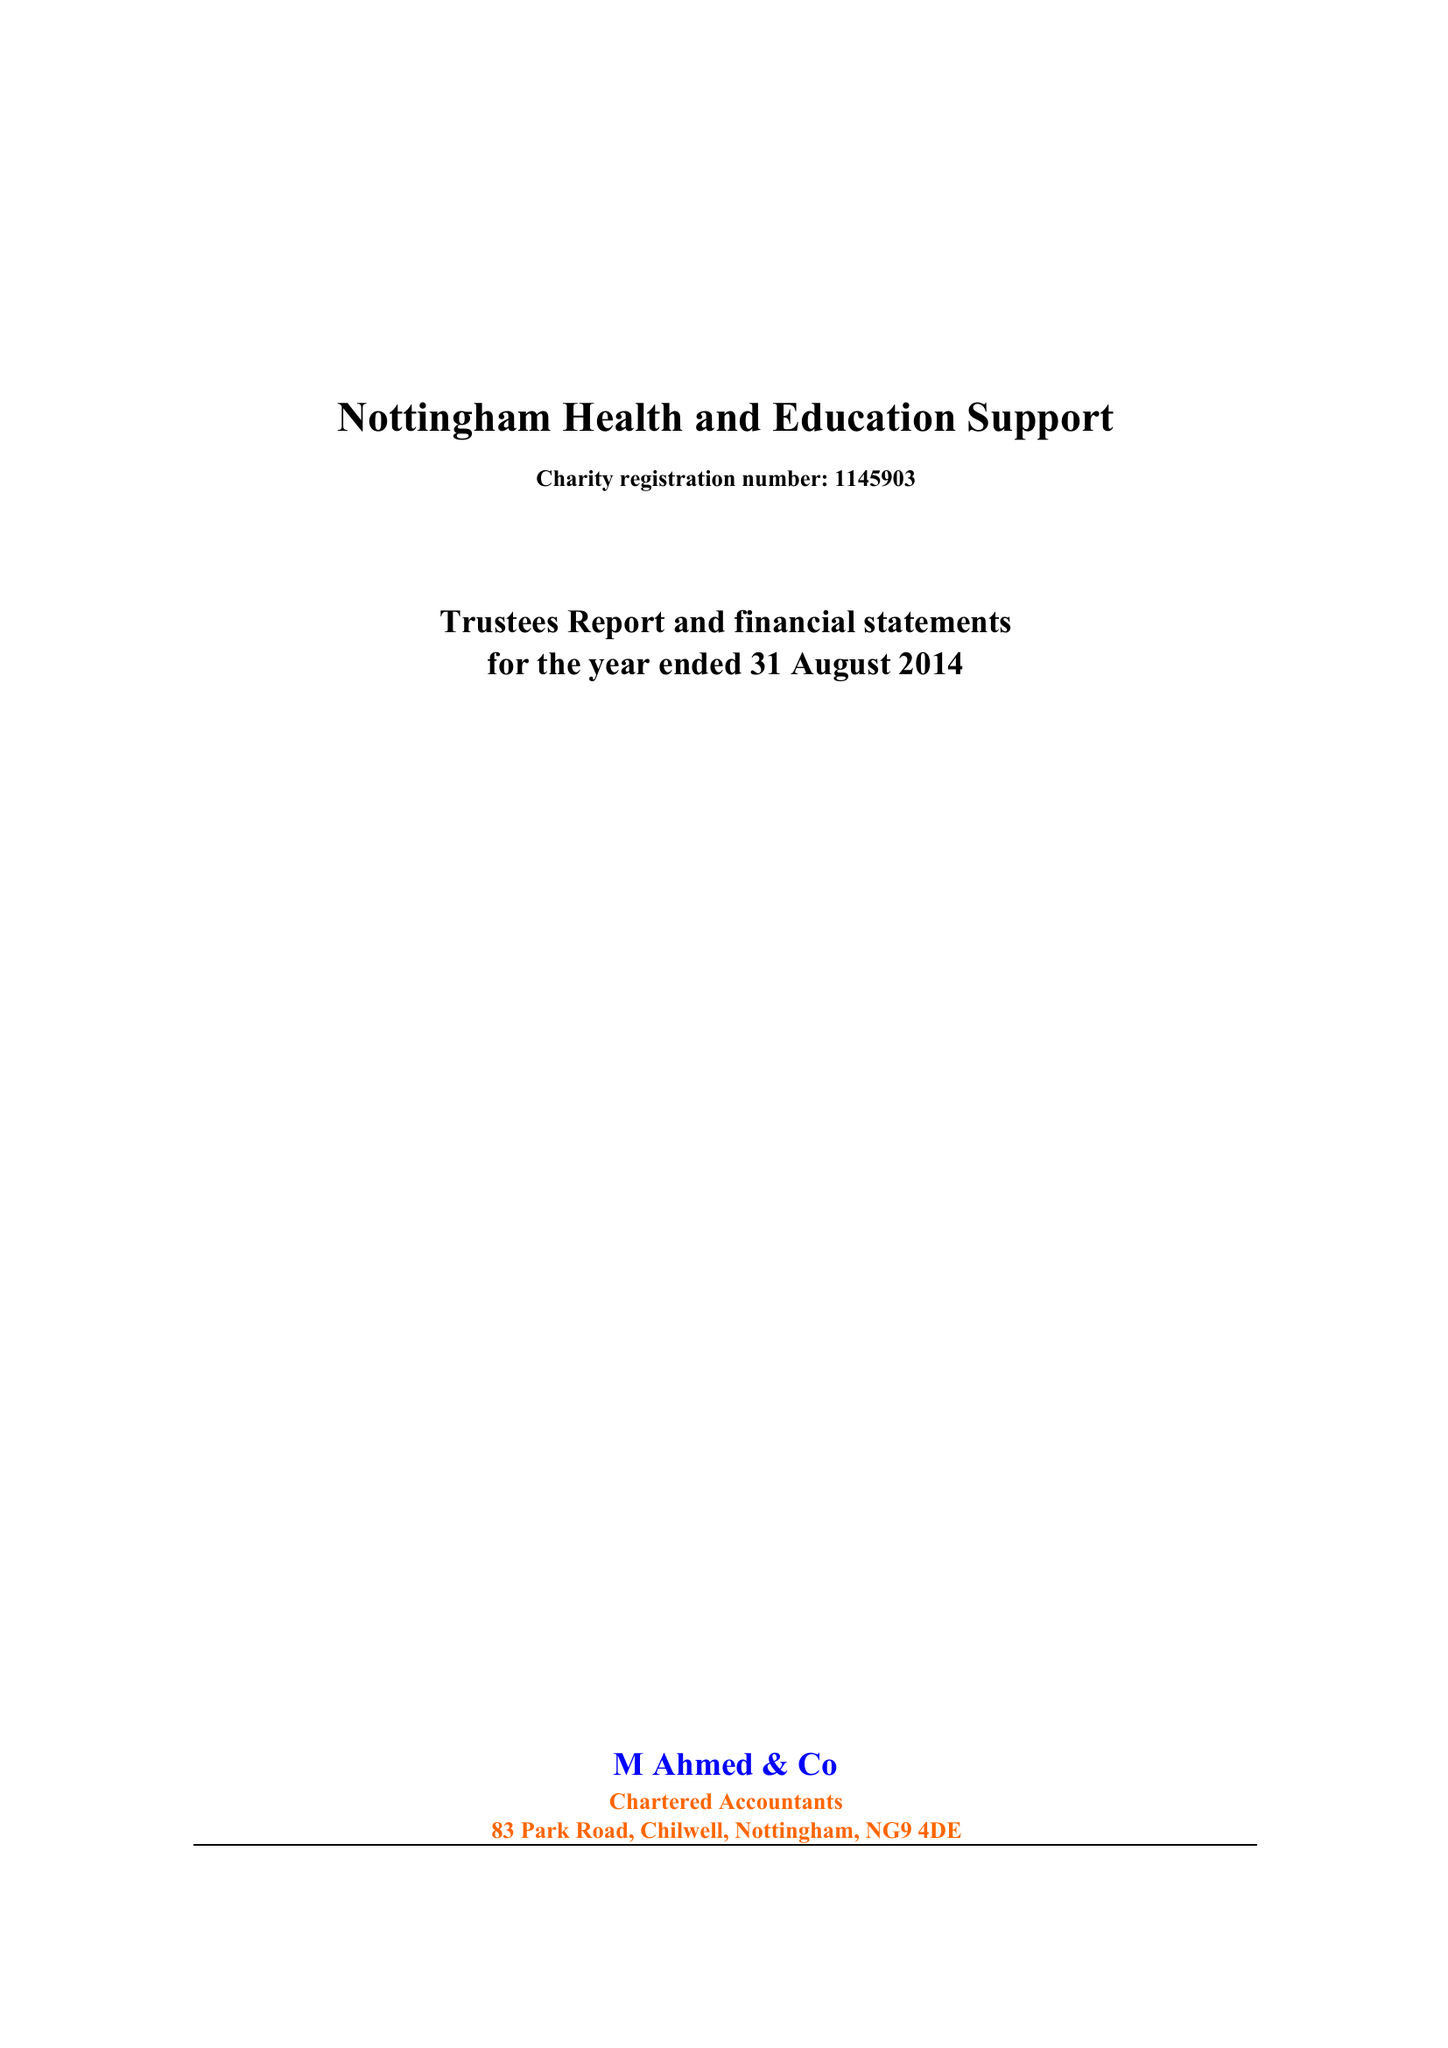What is the value for the spending_annually_in_british_pounds?
Answer the question using a single word or phrase. 72775.00 